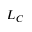Convert formula to latex. <formula><loc_0><loc_0><loc_500><loc_500>L _ { C }</formula> 